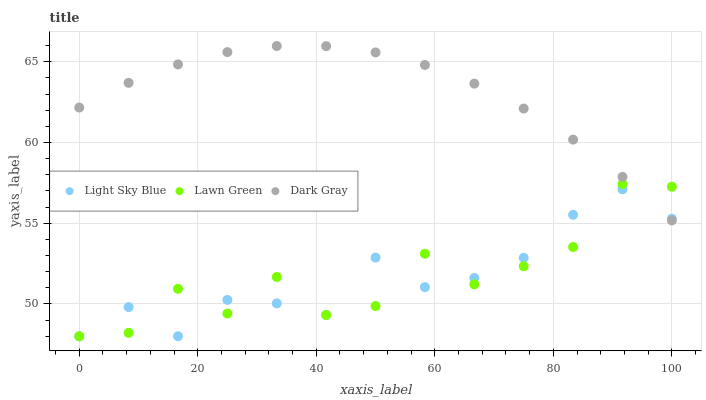Does Lawn Green have the minimum area under the curve?
Answer yes or no. Yes. Does Dark Gray have the maximum area under the curve?
Answer yes or no. Yes. Does Light Sky Blue have the minimum area under the curve?
Answer yes or no. No. Does Light Sky Blue have the maximum area under the curve?
Answer yes or no. No. Is Dark Gray the smoothest?
Answer yes or no. Yes. Is Lawn Green the roughest?
Answer yes or no. Yes. Is Light Sky Blue the smoothest?
Answer yes or no. No. Is Light Sky Blue the roughest?
Answer yes or no. No. Does Lawn Green have the lowest value?
Answer yes or no. Yes. Does Dark Gray have the highest value?
Answer yes or no. Yes. Does Lawn Green have the highest value?
Answer yes or no. No. Does Lawn Green intersect Dark Gray?
Answer yes or no. Yes. Is Lawn Green less than Dark Gray?
Answer yes or no. No. Is Lawn Green greater than Dark Gray?
Answer yes or no. No. 